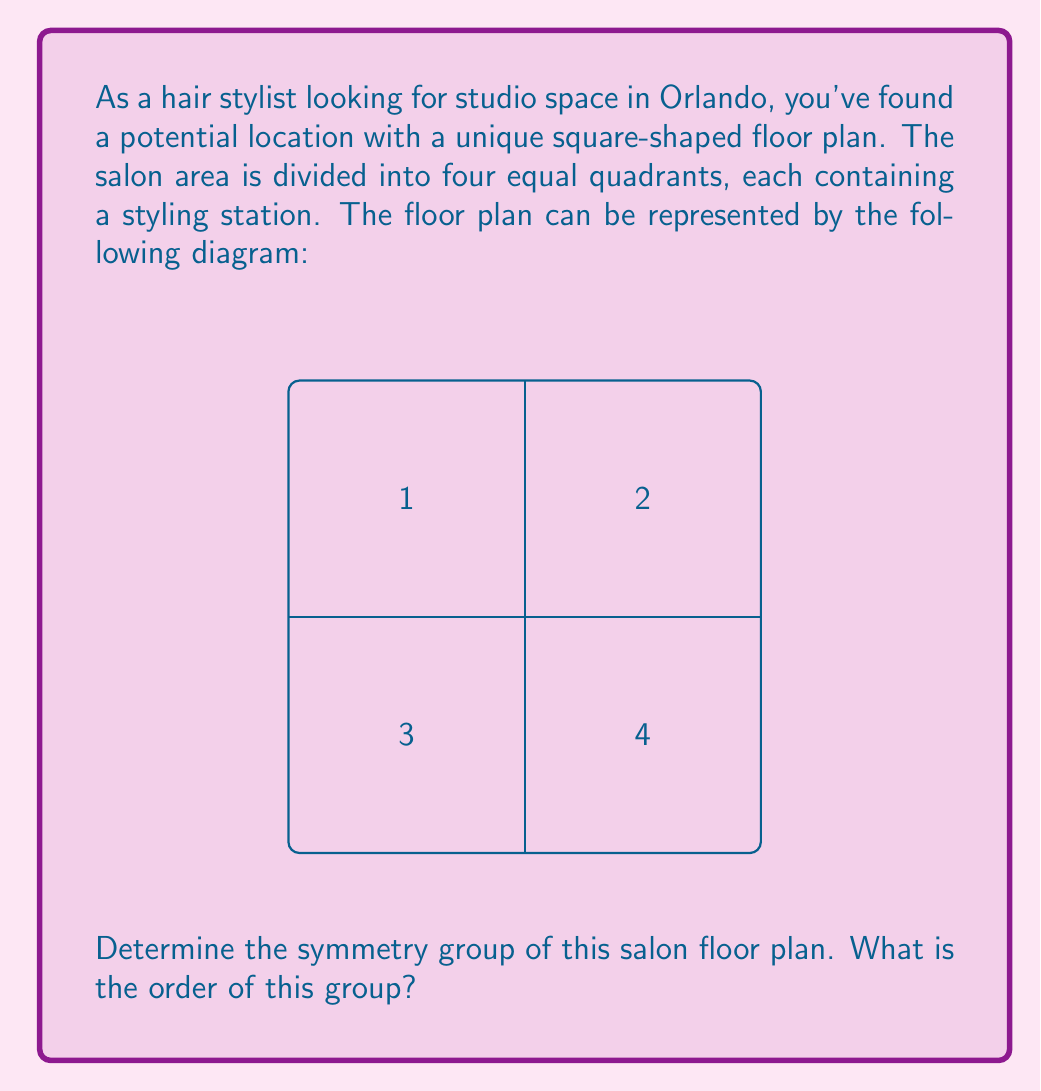Teach me how to tackle this problem. To determine the symmetry group of the salon floor plan, we need to identify all the symmetry operations that leave the floor plan unchanged. Let's approach this step-by-step:

1) Rotational symmetries:
   - 90° clockwise rotation (R90)
   - 180° rotation (R180)
   - 270° clockwise rotation (R270)
   - Identity (no rotation, E)

2) Reflection symmetries:
   - Reflection across the vertical axis (V)
   - Reflection across the horizontal axis (H)
   - Reflection across the diagonal from top-left to bottom-right (D1)
   - Reflection across the diagonal from top-right to bottom-left (D2)

3) These 8 symmetry operations form a group under composition. This group is known as the dihedral group of order 8, denoted as $D_4$ or $D_8$ (depending on the notation system).

4) To verify that this is indeed a group:
   - Closure: Composing any two of these operations results in another operation within the set.
   - Associativity: The composition of symmetry operations is always associative.
   - Identity: The identity operation (E) exists in the set.
   - Inverse: Each operation has an inverse within the set.

5) The group table for $D_4$ would look like this:

   $$ \begin{array}{c|cccccccc}
      & E & R90 & R180 & R270 & V & H & D1 & D2 \\
   \hline
   E  & E & R90 & R180 & R270 & V & H & D1 & D2 \\
   R90 & R90 & R180 & R270 & E & D1 & D2 & H & V \\
   R180 & R180 & R270 & E & R90 & H & V & D2 & D1 \\
   R270 & R270 & E & R90 & R180 & D2 & D1 & V & H \\
   V  & V & D2 & H & D1 & E & R180 & R90 & R270 \\
   H  & H & D1 & V & D2 & R180 & E & R270 & R90 \\
   D1 & D1 & V & D2 & H & R270 & R90 & E & R180 \\
   D2 & D2 & H & D1 & V & R90 & R270 & R180 & E
   \end{array} $$

6) The order of a group is the number of elements in the group. In this case, there are 8 symmetry operations, so the order of the group is 8.

Therefore, the symmetry group of the salon floor plan is the dihedral group $D_4$ (or $D_8$), and its order is 8.
Answer: $D_4$ (or $D_8$), order 8 